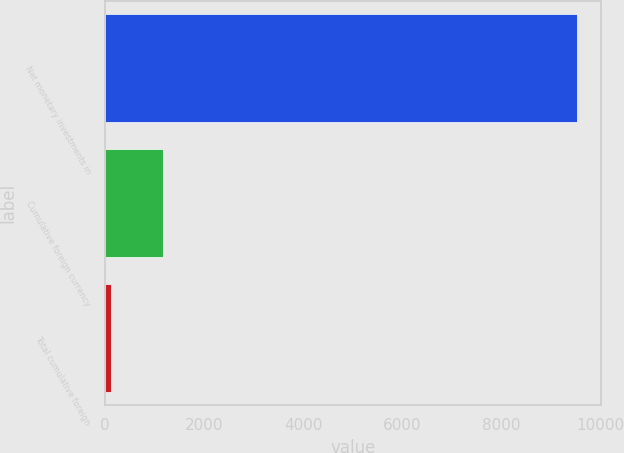Convert chart to OTSL. <chart><loc_0><loc_0><loc_500><loc_500><bar_chart><fcel>Net monetary investments in<fcel>Cumulative foreign currency<fcel>Total cumulative foreign<nl><fcel>9534<fcel>1176<fcel>114<nl></chart> 